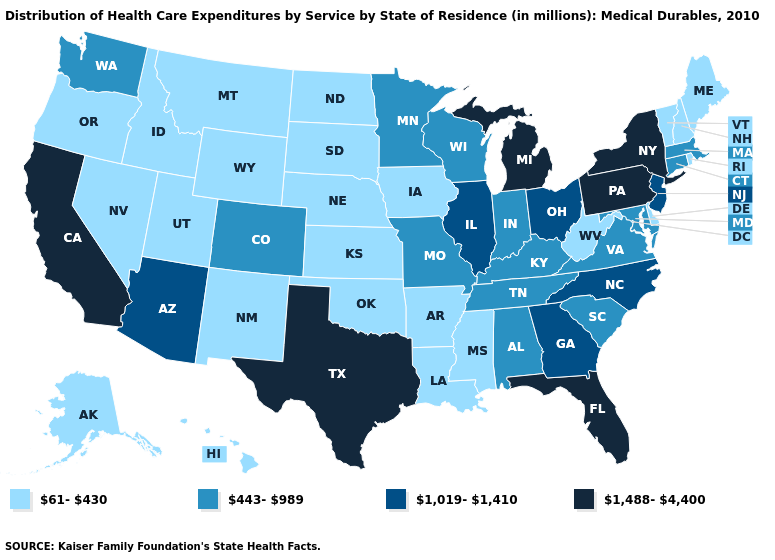Does Arkansas have a lower value than New Hampshire?
Short answer required. No. What is the lowest value in the USA?
Short answer required. 61-430. Does Arizona have a higher value than Florida?
Be succinct. No. What is the lowest value in states that border New Mexico?
Give a very brief answer. 61-430. Name the states that have a value in the range 1,019-1,410?
Keep it brief. Arizona, Georgia, Illinois, New Jersey, North Carolina, Ohio. Does South Dakota have a higher value than West Virginia?
Give a very brief answer. No. Which states have the highest value in the USA?
Give a very brief answer. California, Florida, Michigan, New York, Pennsylvania, Texas. What is the highest value in the USA?
Short answer required. 1,488-4,400. Among the states that border Ohio , does West Virginia have the highest value?
Short answer required. No. Which states have the lowest value in the USA?
Quick response, please. Alaska, Arkansas, Delaware, Hawaii, Idaho, Iowa, Kansas, Louisiana, Maine, Mississippi, Montana, Nebraska, Nevada, New Hampshire, New Mexico, North Dakota, Oklahoma, Oregon, Rhode Island, South Dakota, Utah, Vermont, West Virginia, Wyoming. Does New York have a higher value than Pennsylvania?
Answer briefly. No. Name the states that have a value in the range 443-989?
Give a very brief answer. Alabama, Colorado, Connecticut, Indiana, Kentucky, Maryland, Massachusetts, Minnesota, Missouri, South Carolina, Tennessee, Virginia, Washington, Wisconsin. Does South Dakota have the lowest value in the USA?
Concise answer only. Yes. What is the lowest value in the USA?
Answer briefly. 61-430. Does Florida have the highest value in the USA?
Answer briefly. Yes. 